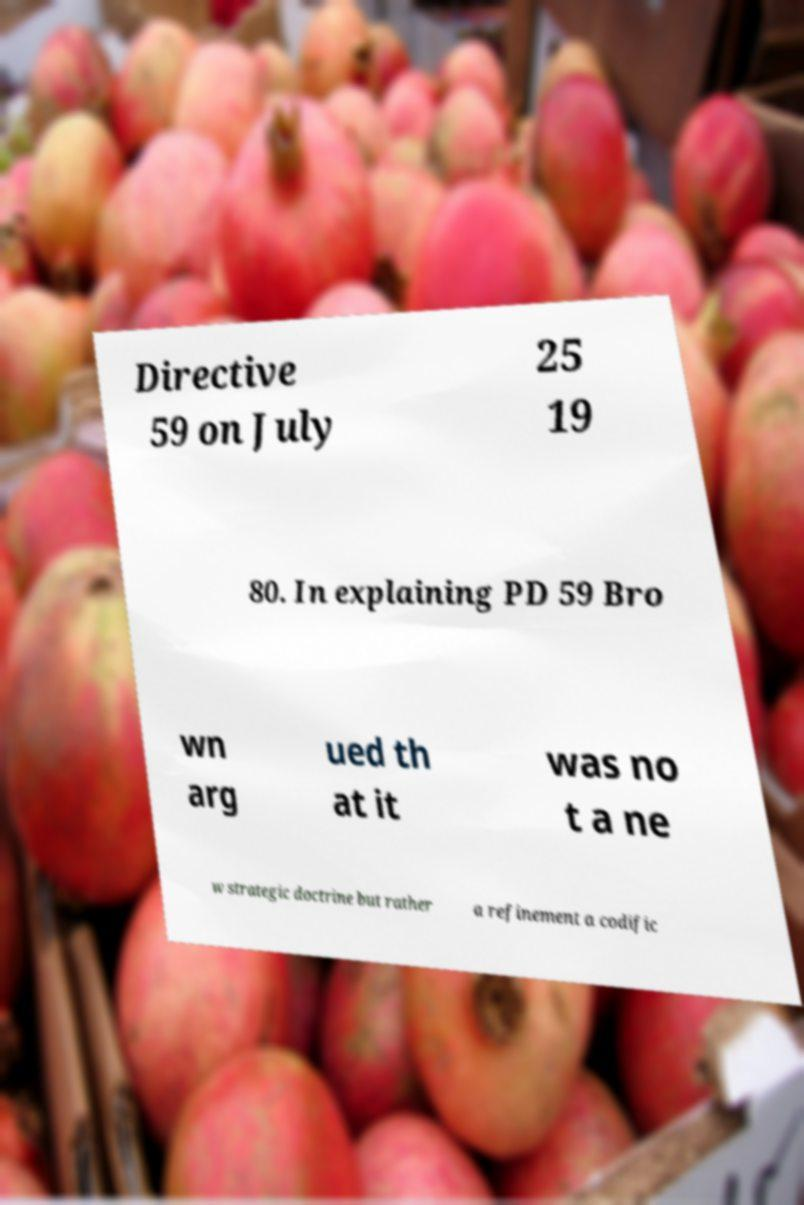I need the written content from this picture converted into text. Can you do that? Directive 59 on July 25 19 80. In explaining PD 59 Bro wn arg ued th at it was no t a ne w strategic doctrine but rather a refinement a codific 